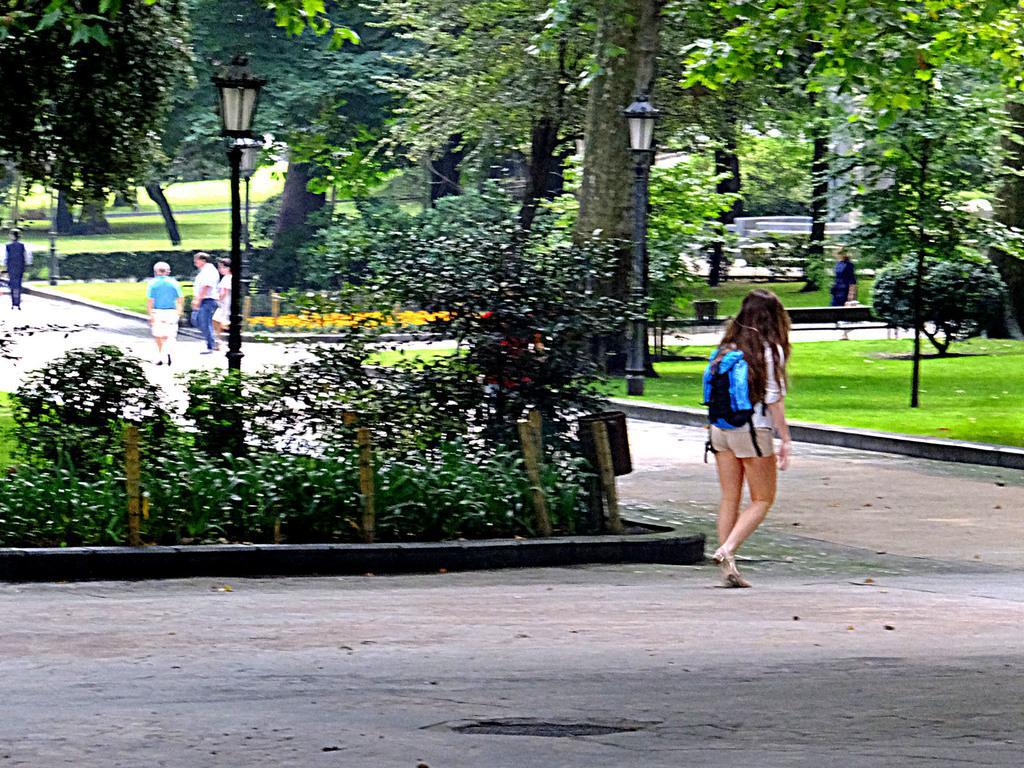Could you give a brief overview of what you see in this image? In this image in the center there are plants and there is a woman walking wearing a black colour bag. In the background there are poles, trees, persons and there's grass on the ground. 